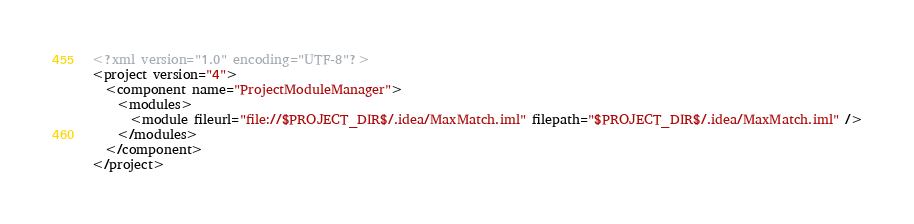Convert code to text. <code><loc_0><loc_0><loc_500><loc_500><_XML_><?xml version="1.0" encoding="UTF-8"?>
<project version="4">
  <component name="ProjectModuleManager">
    <modules>
      <module fileurl="file://$PROJECT_DIR$/.idea/MaxMatch.iml" filepath="$PROJECT_DIR$/.idea/MaxMatch.iml" />
    </modules>
  </component>
</project></code> 